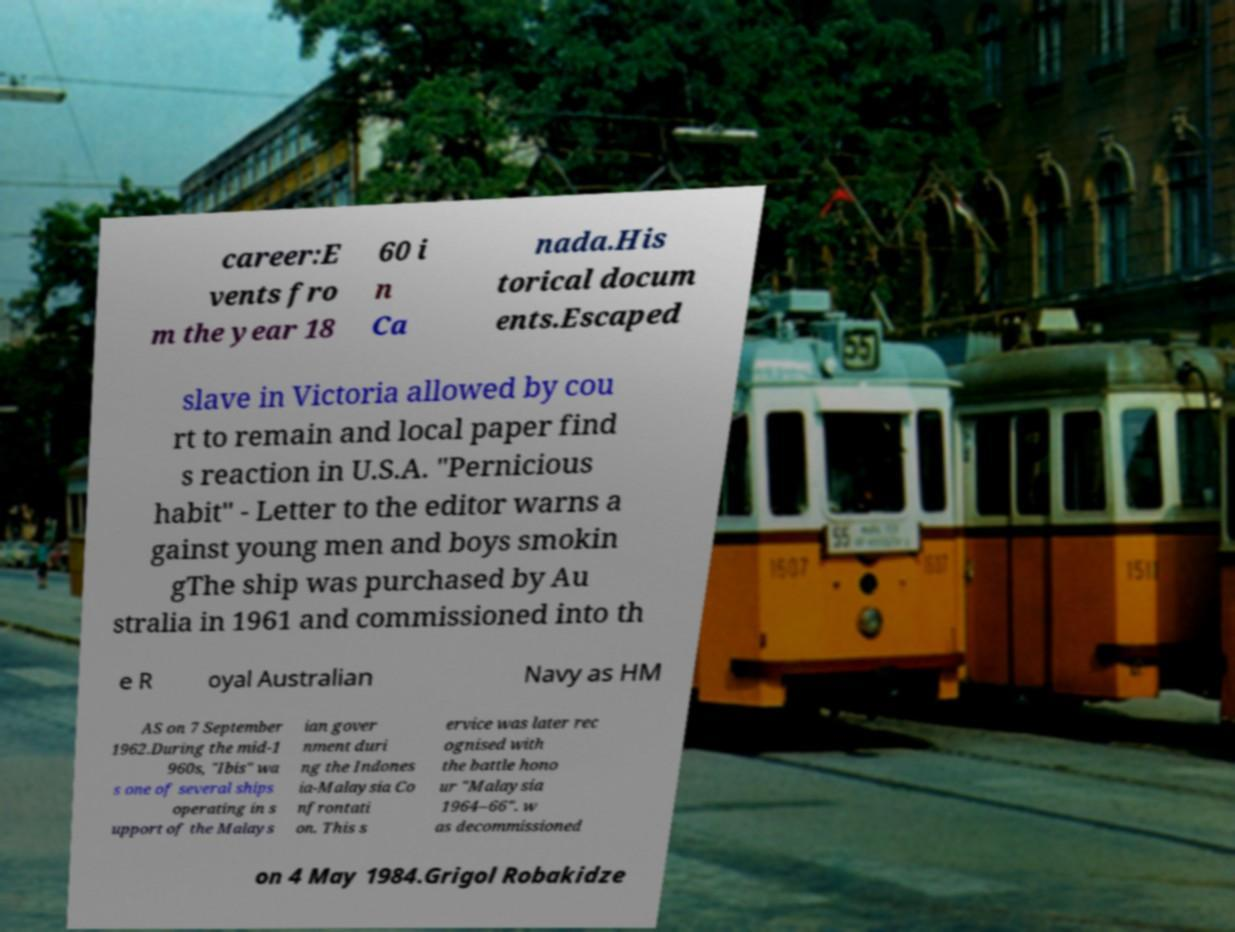Can you read and provide the text displayed in the image?This photo seems to have some interesting text. Can you extract and type it out for me? career:E vents fro m the year 18 60 i n Ca nada.His torical docum ents.Escaped slave in Victoria allowed by cou rt to remain and local paper find s reaction in U.S.A. "Pernicious habit" - Letter to the editor warns a gainst young men and boys smokin gThe ship was purchased by Au stralia in 1961 and commissioned into th e R oyal Australian Navy as HM AS on 7 September 1962.During the mid-1 960s, "Ibis" wa s one of several ships operating in s upport of the Malays ian gover nment duri ng the Indones ia-Malaysia Co nfrontati on. This s ervice was later rec ognised with the battle hono ur "Malaysia 1964–66". w as decommissioned on 4 May 1984.Grigol Robakidze 